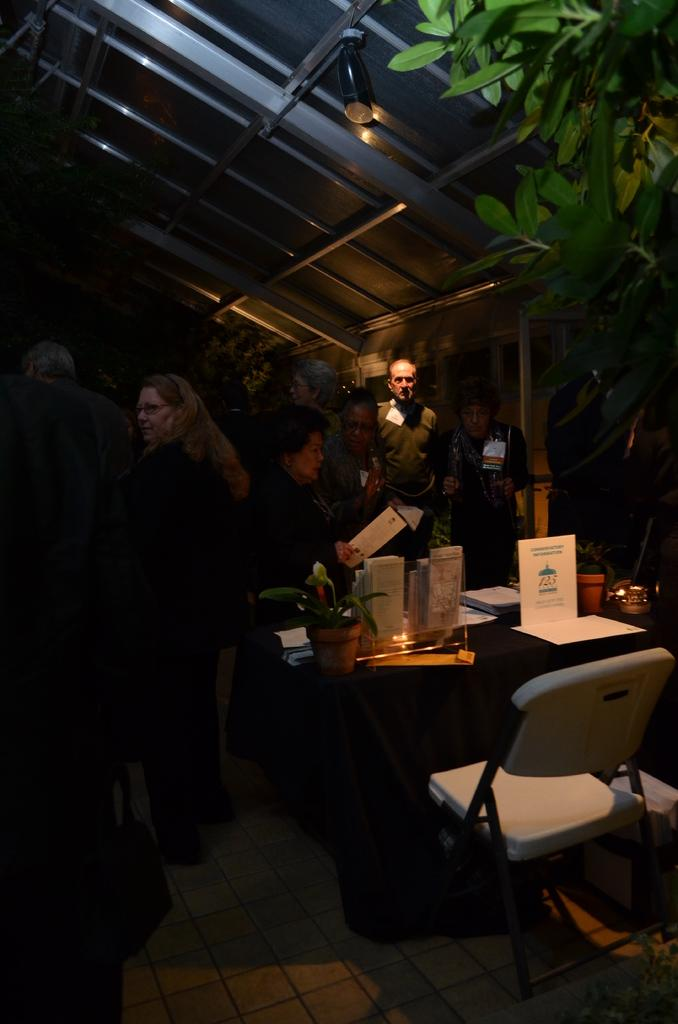What is the overall lighting condition in the image? The image is somewhat dark. What can be seen on the right side of the image? There is a tree on the right side of the image. Who or what is present in the image? There are people in the image. What type of furniture is visible in the image? There is a table and a chair in the image. What items are on the table in the image? There are posters and bowls on the table. How many cars are parked in front of the tree in the image? There are no cars visible in the image; it only features a tree, people, table, chair, posters, and bowls. What type of cord is connected to the posters on the table? There is no cord connected to the posters on the table in the image. 